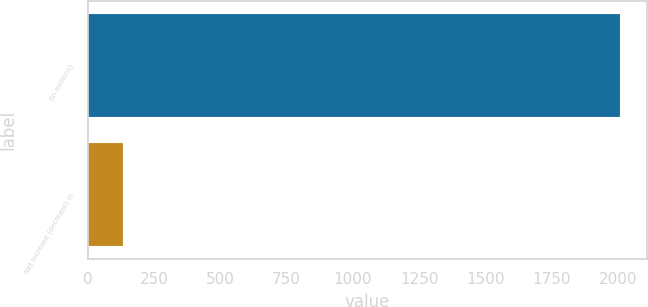<chart> <loc_0><loc_0><loc_500><loc_500><bar_chart><fcel>(In millions)<fcel>Net increase (decrease) in<nl><fcel>2008<fcel>134<nl></chart> 